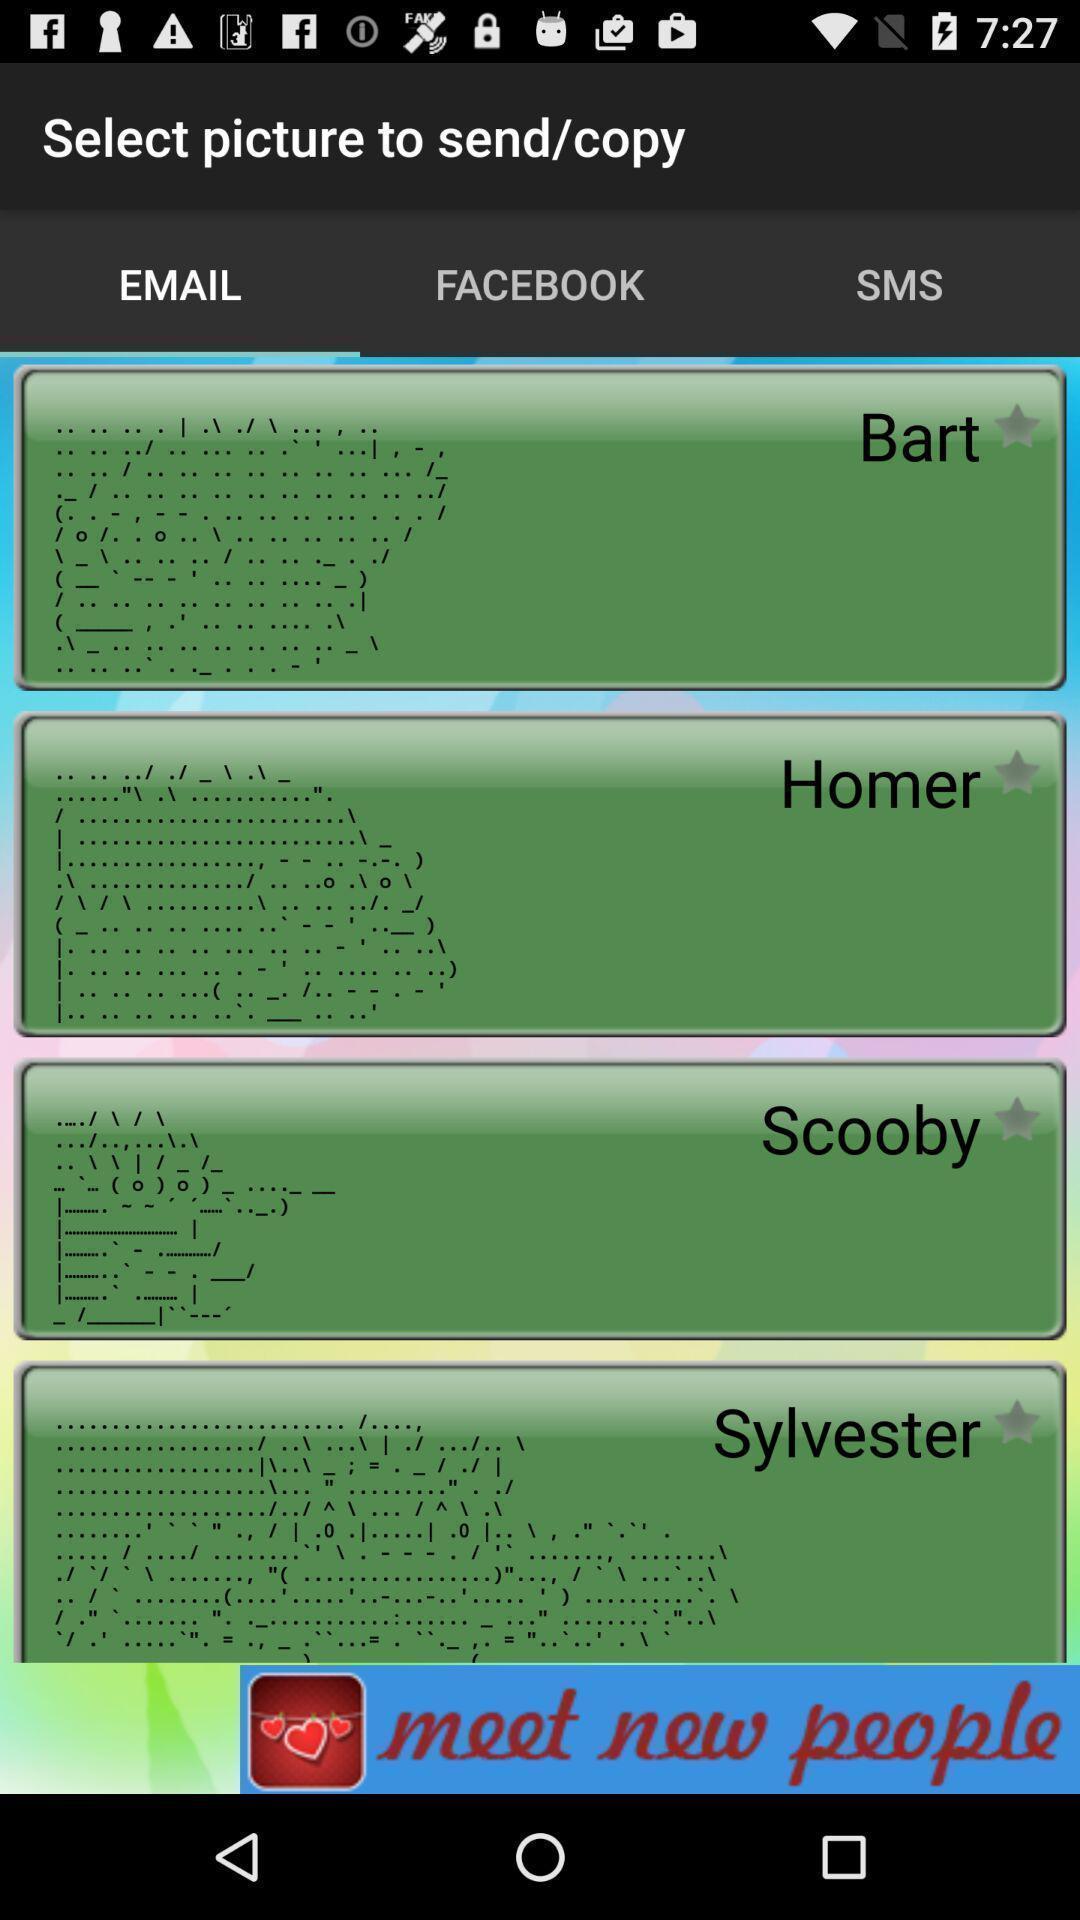What is the overall content of this screenshot? Screen displaying option for select picture to send/copy. 